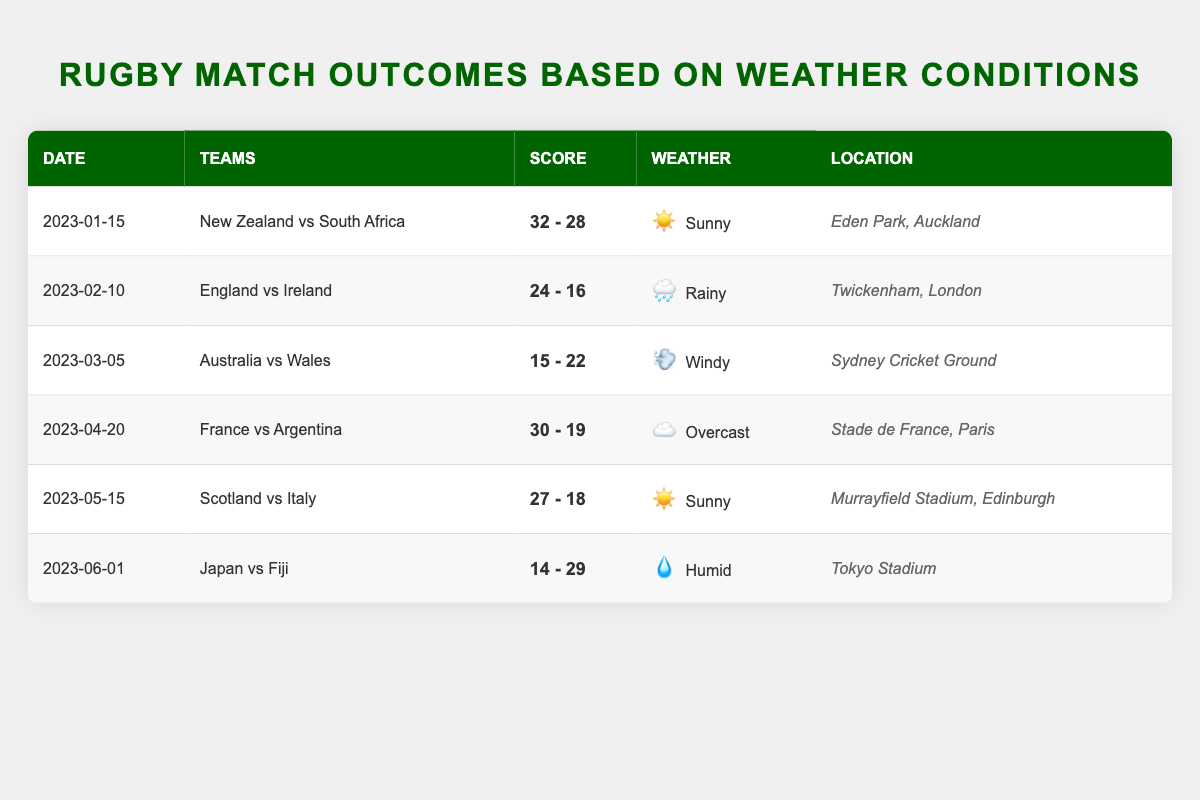What was the score of the match between New Zealand and South Africa? The table shows that on January 15, 2023, New Zealand played against South Africa, and the score was New Zealand 32, South Africa 28.
Answer: 32 - 28 How many matches were played in sunny weather? Looking through the table, the matches in sunny weather were: New Zealand vs South Africa and Scotland vs Italy. There are a total of 2 matches listed that were played in sunny weather.
Answer: 2 Did England win against Ireland? In the match on February 10, 2023, the score was England 24, Ireland 16. Since England scored higher than Ireland, we can conclude that England won the match.
Answer: Yes What was the total number of points scored in the match between Australia and Wales? The match between Australia and Wales, which took place on March 5, 2023, had scores 15 for Australia and 22 for Wales. To find the total points, add the two scores: 15 + 22 = 37.
Answer: 37 Which match had the highest score difference, and what was that difference? To find the highest score difference, we calculate the difference for each match: NZ vs SA: 4, England vs Ireland: 8, Australia vs Wales: 7, France vs Argentina: 11, Scotland vs Italy: 9, Japan vs Fiji: 15. The highest score difference is from the Japan vs Fiji match with 15 points (29 - 14).
Answer: Japan vs Fiji, 15 points 